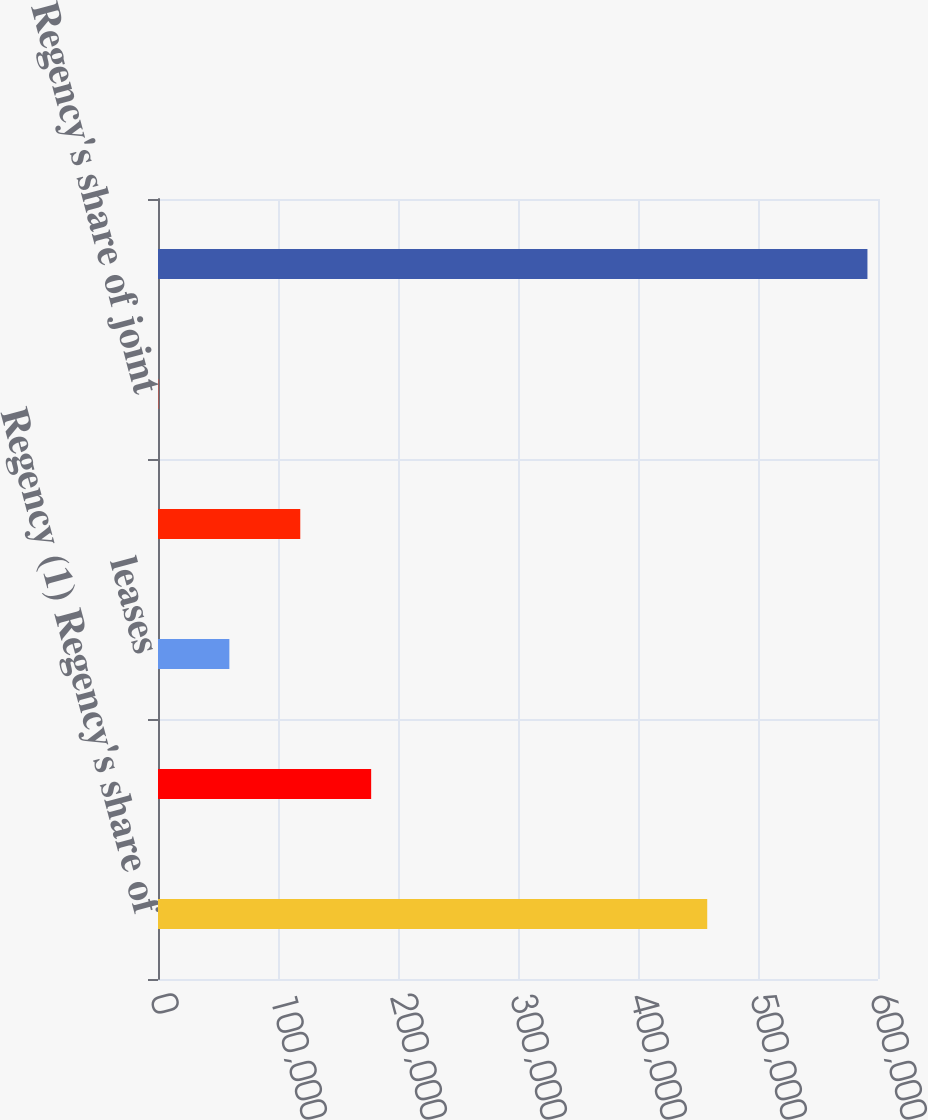Convert chart to OTSL. <chart><loc_0><loc_0><loc_500><loc_500><bar_chart><fcel>Regency (1) Regency's share of<fcel>joint ventures<fcel>leases<fcel>Regency<fcel>Regency's share of joint<fcel>Total<nl><fcel>457680<fcel>177636<fcel>59474.6<fcel>118555<fcel>394<fcel>591200<nl></chart> 